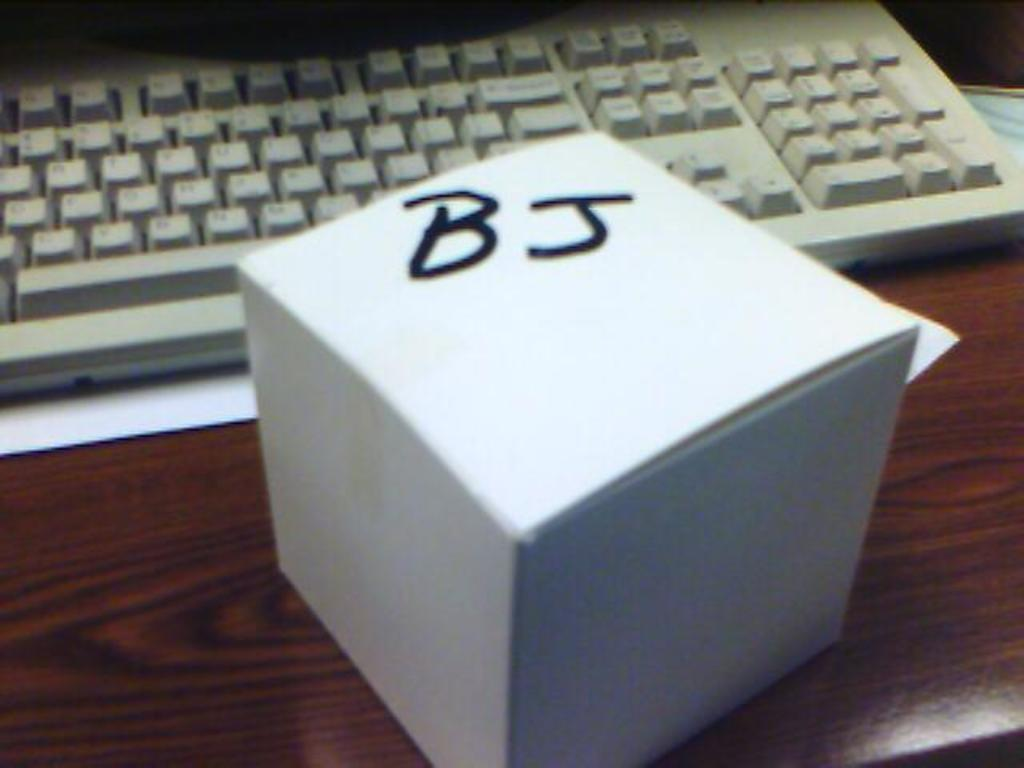<image>
Summarize the visual content of the image. A small closed white box with the letters BJ is on a desk in front of a keyboard. 